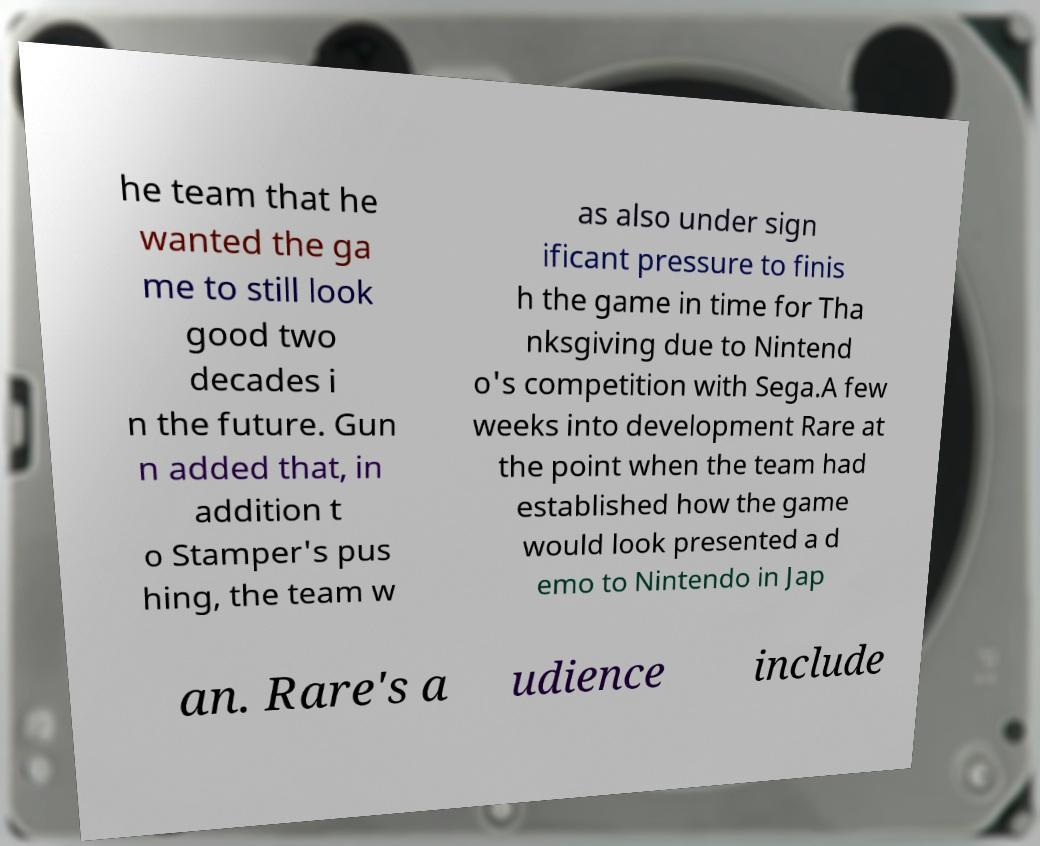Could you extract and type out the text from this image? he team that he wanted the ga me to still look good two decades i n the future. Gun n added that, in addition t o Stamper's pus hing, the team w as also under sign ificant pressure to finis h the game in time for Tha nksgiving due to Nintend o's competition with Sega.A few weeks into development Rare at the point when the team had established how the game would look presented a d emo to Nintendo in Jap an. Rare's a udience include 